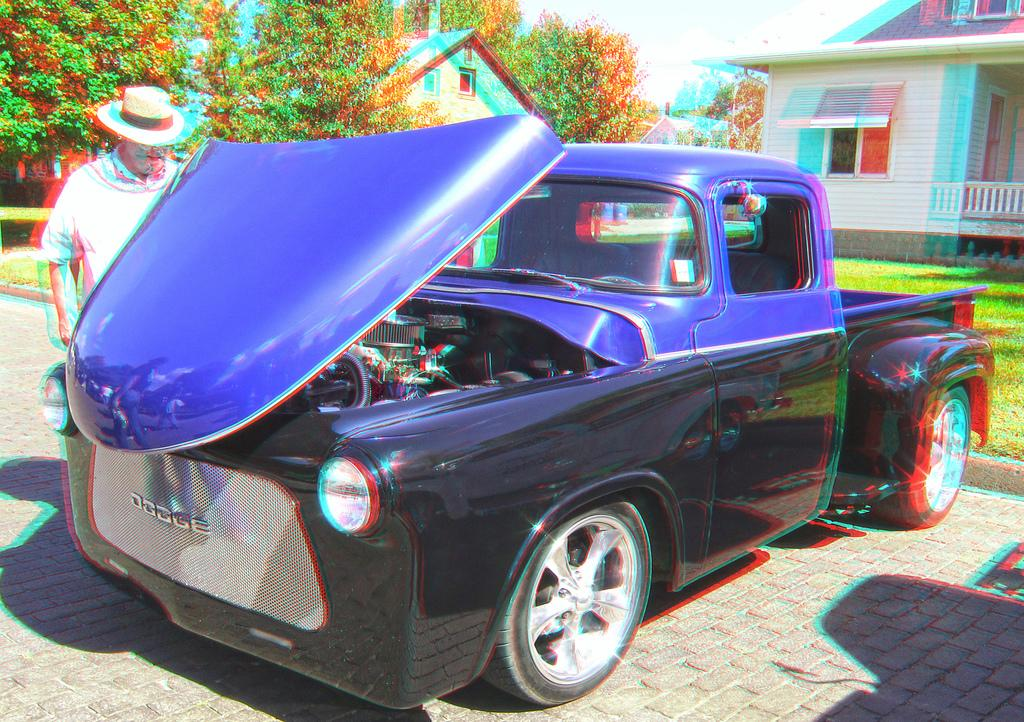What is the main subject in the front of the image? There is a car in the front of the image. Who or what is also present in the front of the image? There is a person standing in the front of the image. What can be seen in the background of the image? There are trees and houses in the background of the image. What type of ground surface is visible in the image? There is grass on the ground in the image. What type of poisonous plant can be seen growing near the car in the image? There is no poisonous plant visible in the image; it only features a car, a person, trees, houses, and grass. 